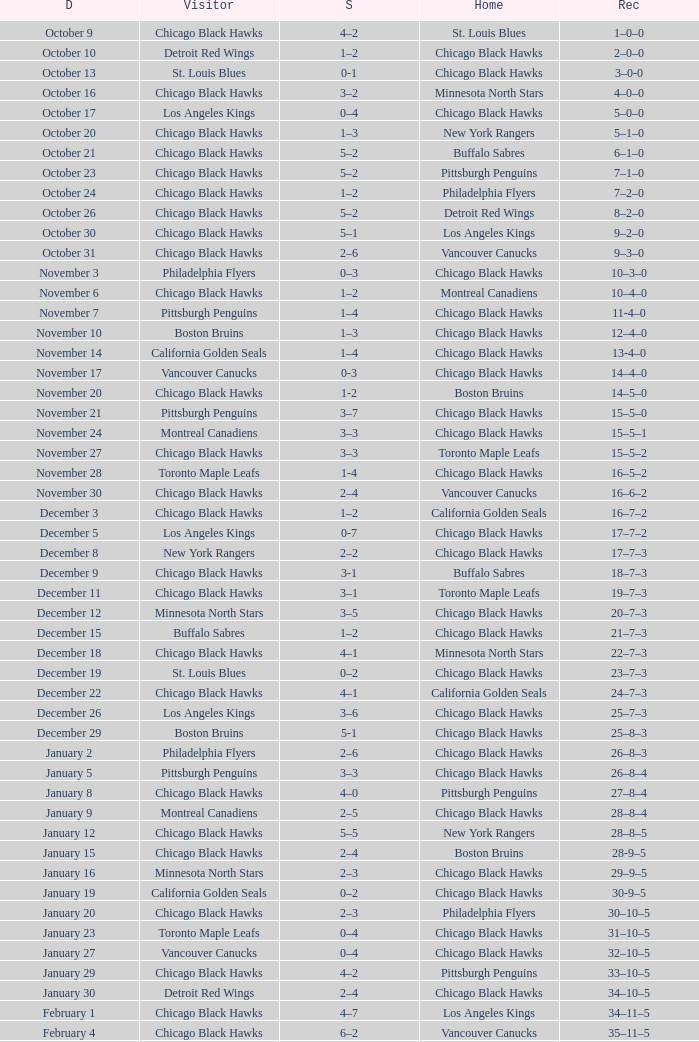What is the Record of the February 26 date? 39–16–7. 